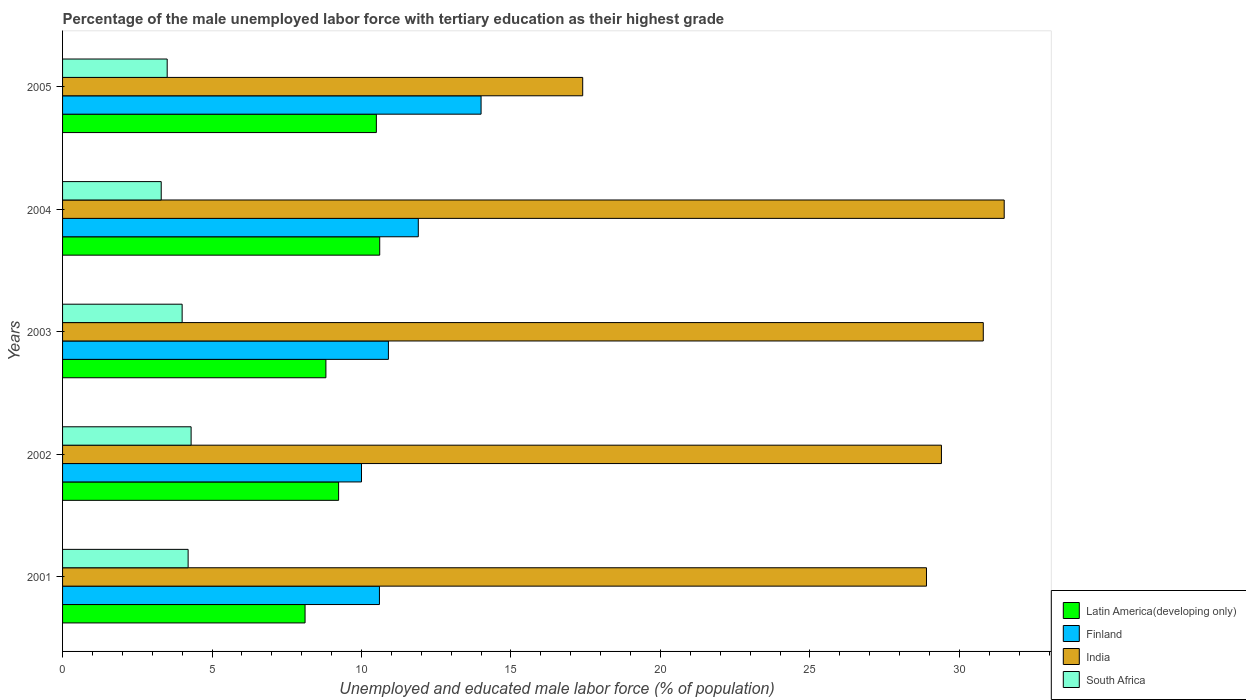How many groups of bars are there?
Keep it short and to the point. 5. Are the number of bars per tick equal to the number of legend labels?
Offer a terse response. Yes. How many bars are there on the 1st tick from the top?
Ensure brevity in your answer.  4. What is the label of the 1st group of bars from the top?
Ensure brevity in your answer.  2005. What is the percentage of the unemployed male labor force with tertiary education in India in 2002?
Offer a terse response. 29.4. Across all years, what is the maximum percentage of the unemployed male labor force with tertiary education in South Africa?
Keep it short and to the point. 4.3. Across all years, what is the minimum percentage of the unemployed male labor force with tertiary education in Latin America(developing only)?
Your response must be concise. 8.11. In which year was the percentage of the unemployed male labor force with tertiary education in South Africa minimum?
Provide a succinct answer. 2004. What is the total percentage of the unemployed male labor force with tertiary education in India in the graph?
Provide a succinct answer. 138. What is the difference between the percentage of the unemployed male labor force with tertiary education in India in 2003 and that in 2004?
Your response must be concise. -0.7. What is the average percentage of the unemployed male labor force with tertiary education in Finland per year?
Provide a succinct answer. 11.48. In the year 2002, what is the difference between the percentage of the unemployed male labor force with tertiary education in India and percentage of the unemployed male labor force with tertiary education in Latin America(developing only)?
Offer a very short reply. 20.17. What is the ratio of the percentage of the unemployed male labor force with tertiary education in Latin America(developing only) in 2003 to that in 2004?
Give a very brief answer. 0.83. Is the percentage of the unemployed male labor force with tertiary education in Latin America(developing only) in 2002 less than that in 2004?
Give a very brief answer. Yes. Is the difference between the percentage of the unemployed male labor force with tertiary education in India in 2003 and 2004 greater than the difference between the percentage of the unemployed male labor force with tertiary education in Latin America(developing only) in 2003 and 2004?
Make the answer very short. Yes. What is the difference between the highest and the second highest percentage of the unemployed male labor force with tertiary education in India?
Provide a short and direct response. 0.7. In how many years, is the percentage of the unemployed male labor force with tertiary education in South Africa greater than the average percentage of the unemployed male labor force with tertiary education in South Africa taken over all years?
Provide a short and direct response. 3. Is the sum of the percentage of the unemployed male labor force with tertiary education in Finland in 2002 and 2003 greater than the maximum percentage of the unemployed male labor force with tertiary education in Latin America(developing only) across all years?
Make the answer very short. Yes. What does the 2nd bar from the bottom in 2003 represents?
Ensure brevity in your answer.  Finland. Is it the case that in every year, the sum of the percentage of the unemployed male labor force with tertiary education in South Africa and percentage of the unemployed male labor force with tertiary education in Finland is greater than the percentage of the unemployed male labor force with tertiary education in Latin America(developing only)?
Provide a succinct answer. Yes. How many years are there in the graph?
Your answer should be compact. 5. Are the values on the major ticks of X-axis written in scientific E-notation?
Your answer should be very brief. No. Does the graph contain any zero values?
Offer a terse response. No. Does the graph contain grids?
Offer a very short reply. No. How many legend labels are there?
Ensure brevity in your answer.  4. How are the legend labels stacked?
Give a very brief answer. Vertical. What is the title of the graph?
Provide a succinct answer. Percentage of the male unemployed labor force with tertiary education as their highest grade. Does "Middle East & North Africa (all income levels)" appear as one of the legend labels in the graph?
Give a very brief answer. No. What is the label or title of the X-axis?
Offer a very short reply. Unemployed and educated male labor force (% of population). What is the label or title of the Y-axis?
Your answer should be very brief. Years. What is the Unemployed and educated male labor force (% of population) of Latin America(developing only) in 2001?
Your answer should be compact. 8.11. What is the Unemployed and educated male labor force (% of population) in Finland in 2001?
Keep it short and to the point. 10.6. What is the Unemployed and educated male labor force (% of population) of India in 2001?
Provide a short and direct response. 28.9. What is the Unemployed and educated male labor force (% of population) of South Africa in 2001?
Provide a short and direct response. 4.2. What is the Unemployed and educated male labor force (% of population) in Latin America(developing only) in 2002?
Keep it short and to the point. 9.23. What is the Unemployed and educated male labor force (% of population) of India in 2002?
Give a very brief answer. 29.4. What is the Unemployed and educated male labor force (% of population) in South Africa in 2002?
Offer a very short reply. 4.3. What is the Unemployed and educated male labor force (% of population) of Latin America(developing only) in 2003?
Your answer should be very brief. 8.81. What is the Unemployed and educated male labor force (% of population) of Finland in 2003?
Offer a terse response. 10.9. What is the Unemployed and educated male labor force (% of population) of India in 2003?
Offer a very short reply. 30.8. What is the Unemployed and educated male labor force (% of population) in Latin America(developing only) in 2004?
Your answer should be compact. 10.61. What is the Unemployed and educated male labor force (% of population) of Finland in 2004?
Keep it short and to the point. 11.9. What is the Unemployed and educated male labor force (% of population) in India in 2004?
Your response must be concise. 31.5. What is the Unemployed and educated male labor force (% of population) of South Africa in 2004?
Make the answer very short. 3.3. What is the Unemployed and educated male labor force (% of population) of Latin America(developing only) in 2005?
Your answer should be compact. 10.5. What is the Unemployed and educated male labor force (% of population) in Finland in 2005?
Give a very brief answer. 14. What is the Unemployed and educated male labor force (% of population) of India in 2005?
Ensure brevity in your answer.  17.4. What is the Unemployed and educated male labor force (% of population) in South Africa in 2005?
Your answer should be compact. 3.5. Across all years, what is the maximum Unemployed and educated male labor force (% of population) of Latin America(developing only)?
Your response must be concise. 10.61. Across all years, what is the maximum Unemployed and educated male labor force (% of population) in Finland?
Make the answer very short. 14. Across all years, what is the maximum Unemployed and educated male labor force (% of population) of India?
Your answer should be very brief. 31.5. Across all years, what is the maximum Unemployed and educated male labor force (% of population) of South Africa?
Make the answer very short. 4.3. Across all years, what is the minimum Unemployed and educated male labor force (% of population) in Latin America(developing only)?
Your answer should be very brief. 8.11. Across all years, what is the minimum Unemployed and educated male labor force (% of population) in India?
Make the answer very short. 17.4. Across all years, what is the minimum Unemployed and educated male labor force (% of population) in South Africa?
Ensure brevity in your answer.  3.3. What is the total Unemployed and educated male labor force (% of population) in Latin America(developing only) in the graph?
Keep it short and to the point. 47.26. What is the total Unemployed and educated male labor force (% of population) in Finland in the graph?
Your answer should be very brief. 57.4. What is the total Unemployed and educated male labor force (% of population) of India in the graph?
Keep it short and to the point. 138. What is the total Unemployed and educated male labor force (% of population) in South Africa in the graph?
Provide a succinct answer. 19.3. What is the difference between the Unemployed and educated male labor force (% of population) in Latin America(developing only) in 2001 and that in 2002?
Provide a short and direct response. -1.12. What is the difference between the Unemployed and educated male labor force (% of population) in Finland in 2001 and that in 2002?
Offer a very short reply. 0.6. What is the difference between the Unemployed and educated male labor force (% of population) in Latin America(developing only) in 2001 and that in 2003?
Offer a very short reply. -0.7. What is the difference between the Unemployed and educated male labor force (% of population) of Finland in 2001 and that in 2003?
Provide a succinct answer. -0.3. What is the difference between the Unemployed and educated male labor force (% of population) in India in 2001 and that in 2003?
Your response must be concise. -1.9. What is the difference between the Unemployed and educated male labor force (% of population) in Latin America(developing only) in 2001 and that in 2004?
Your response must be concise. -2.5. What is the difference between the Unemployed and educated male labor force (% of population) in Finland in 2001 and that in 2004?
Your response must be concise. -1.3. What is the difference between the Unemployed and educated male labor force (% of population) of India in 2001 and that in 2004?
Your answer should be very brief. -2.6. What is the difference between the Unemployed and educated male labor force (% of population) in Latin America(developing only) in 2001 and that in 2005?
Your response must be concise. -2.38. What is the difference between the Unemployed and educated male labor force (% of population) in Finland in 2001 and that in 2005?
Offer a terse response. -3.4. What is the difference between the Unemployed and educated male labor force (% of population) in India in 2001 and that in 2005?
Provide a short and direct response. 11.5. What is the difference between the Unemployed and educated male labor force (% of population) in South Africa in 2001 and that in 2005?
Keep it short and to the point. 0.7. What is the difference between the Unemployed and educated male labor force (% of population) of Latin America(developing only) in 2002 and that in 2003?
Give a very brief answer. 0.43. What is the difference between the Unemployed and educated male labor force (% of population) of Finland in 2002 and that in 2003?
Offer a terse response. -0.9. What is the difference between the Unemployed and educated male labor force (% of population) of India in 2002 and that in 2003?
Your answer should be very brief. -1.4. What is the difference between the Unemployed and educated male labor force (% of population) of South Africa in 2002 and that in 2003?
Give a very brief answer. 0.3. What is the difference between the Unemployed and educated male labor force (% of population) in Latin America(developing only) in 2002 and that in 2004?
Ensure brevity in your answer.  -1.37. What is the difference between the Unemployed and educated male labor force (% of population) of India in 2002 and that in 2004?
Ensure brevity in your answer.  -2.1. What is the difference between the Unemployed and educated male labor force (% of population) in South Africa in 2002 and that in 2004?
Offer a terse response. 1. What is the difference between the Unemployed and educated male labor force (% of population) in Latin America(developing only) in 2002 and that in 2005?
Provide a short and direct response. -1.26. What is the difference between the Unemployed and educated male labor force (% of population) in Finland in 2002 and that in 2005?
Provide a succinct answer. -4. What is the difference between the Unemployed and educated male labor force (% of population) of South Africa in 2002 and that in 2005?
Make the answer very short. 0.8. What is the difference between the Unemployed and educated male labor force (% of population) of Latin America(developing only) in 2003 and that in 2004?
Offer a terse response. -1.8. What is the difference between the Unemployed and educated male labor force (% of population) of Finland in 2003 and that in 2004?
Make the answer very short. -1. What is the difference between the Unemployed and educated male labor force (% of population) in Latin America(developing only) in 2003 and that in 2005?
Provide a succinct answer. -1.69. What is the difference between the Unemployed and educated male labor force (% of population) in Finland in 2003 and that in 2005?
Ensure brevity in your answer.  -3.1. What is the difference between the Unemployed and educated male labor force (% of population) of South Africa in 2003 and that in 2005?
Your answer should be compact. 0.5. What is the difference between the Unemployed and educated male labor force (% of population) in Latin America(developing only) in 2004 and that in 2005?
Ensure brevity in your answer.  0.11. What is the difference between the Unemployed and educated male labor force (% of population) in India in 2004 and that in 2005?
Provide a short and direct response. 14.1. What is the difference between the Unemployed and educated male labor force (% of population) of South Africa in 2004 and that in 2005?
Ensure brevity in your answer.  -0.2. What is the difference between the Unemployed and educated male labor force (% of population) in Latin America(developing only) in 2001 and the Unemployed and educated male labor force (% of population) in Finland in 2002?
Give a very brief answer. -1.89. What is the difference between the Unemployed and educated male labor force (% of population) in Latin America(developing only) in 2001 and the Unemployed and educated male labor force (% of population) in India in 2002?
Offer a very short reply. -21.29. What is the difference between the Unemployed and educated male labor force (% of population) of Latin America(developing only) in 2001 and the Unemployed and educated male labor force (% of population) of South Africa in 2002?
Offer a terse response. 3.81. What is the difference between the Unemployed and educated male labor force (% of population) in Finland in 2001 and the Unemployed and educated male labor force (% of population) in India in 2002?
Offer a very short reply. -18.8. What is the difference between the Unemployed and educated male labor force (% of population) in India in 2001 and the Unemployed and educated male labor force (% of population) in South Africa in 2002?
Offer a terse response. 24.6. What is the difference between the Unemployed and educated male labor force (% of population) of Latin America(developing only) in 2001 and the Unemployed and educated male labor force (% of population) of Finland in 2003?
Give a very brief answer. -2.79. What is the difference between the Unemployed and educated male labor force (% of population) in Latin America(developing only) in 2001 and the Unemployed and educated male labor force (% of population) in India in 2003?
Offer a very short reply. -22.69. What is the difference between the Unemployed and educated male labor force (% of population) in Latin America(developing only) in 2001 and the Unemployed and educated male labor force (% of population) in South Africa in 2003?
Your response must be concise. 4.11. What is the difference between the Unemployed and educated male labor force (% of population) of Finland in 2001 and the Unemployed and educated male labor force (% of population) of India in 2003?
Provide a short and direct response. -20.2. What is the difference between the Unemployed and educated male labor force (% of population) in Finland in 2001 and the Unemployed and educated male labor force (% of population) in South Africa in 2003?
Offer a terse response. 6.6. What is the difference between the Unemployed and educated male labor force (% of population) in India in 2001 and the Unemployed and educated male labor force (% of population) in South Africa in 2003?
Give a very brief answer. 24.9. What is the difference between the Unemployed and educated male labor force (% of population) of Latin America(developing only) in 2001 and the Unemployed and educated male labor force (% of population) of Finland in 2004?
Offer a terse response. -3.79. What is the difference between the Unemployed and educated male labor force (% of population) in Latin America(developing only) in 2001 and the Unemployed and educated male labor force (% of population) in India in 2004?
Make the answer very short. -23.39. What is the difference between the Unemployed and educated male labor force (% of population) in Latin America(developing only) in 2001 and the Unemployed and educated male labor force (% of population) in South Africa in 2004?
Give a very brief answer. 4.81. What is the difference between the Unemployed and educated male labor force (% of population) in Finland in 2001 and the Unemployed and educated male labor force (% of population) in India in 2004?
Provide a short and direct response. -20.9. What is the difference between the Unemployed and educated male labor force (% of population) of Finland in 2001 and the Unemployed and educated male labor force (% of population) of South Africa in 2004?
Provide a succinct answer. 7.3. What is the difference between the Unemployed and educated male labor force (% of population) in India in 2001 and the Unemployed and educated male labor force (% of population) in South Africa in 2004?
Your answer should be compact. 25.6. What is the difference between the Unemployed and educated male labor force (% of population) in Latin America(developing only) in 2001 and the Unemployed and educated male labor force (% of population) in Finland in 2005?
Your response must be concise. -5.89. What is the difference between the Unemployed and educated male labor force (% of population) in Latin America(developing only) in 2001 and the Unemployed and educated male labor force (% of population) in India in 2005?
Provide a succinct answer. -9.29. What is the difference between the Unemployed and educated male labor force (% of population) of Latin America(developing only) in 2001 and the Unemployed and educated male labor force (% of population) of South Africa in 2005?
Provide a short and direct response. 4.61. What is the difference between the Unemployed and educated male labor force (% of population) in Finland in 2001 and the Unemployed and educated male labor force (% of population) in India in 2005?
Offer a very short reply. -6.8. What is the difference between the Unemployed and educated male labor force (% of population) of India in 2001 and the Unemployed and educated male labor force (% of population) of South Africa in 2005?
Ensure brevity in your answer.  25.4. What is the difference between the Unemployed and educated male labor force (% of population) of Latin America(developing only) in 2002 and the Unemployed and educated male labor force (% of population) of Finland in 2003?
Keep it short and to the point. -1.67. What is the difference between the Unemployed and educated male labor force (% of population) of Latin America(developing only) in 2002 and the Unemployed and educated male labor force (% of population) of India in 2003?
Your response must be concise. -21.57. What is the difference between the Unemployed and educated male labor force (% of population) in Latin America(developing only) in 2002 and the Unemployed and educated male labor force (% of population) in South Africa in 2003?
Give a very brief answer. 5.23. What is the difference between the Unemployed and educated male labor force (% of population) of Finland in 2002 and the Unemployed and educated male labor force (% of population) of India in 2003?
Ensure brevity in your answer.  -20.8. What is the difference between the Unemployed and educated male labor force (% of population) of India in 2002 and the Unemployed and educated male labor force (% of population) of South Africa in 2003?
Provide a short and direct response. 25.4. What is the difference between the Unemployed and educated male labor force (% of population) of Latin America(developing only) in 2002 and the Unemployed and educated male labor force (% of population) of Finland in 2004?
Offer a terse response. -2.67. What is the difference between the Unemployed and educated male labor force (% of population) in Latin America(developing only) in 2002 and the Unemployed and educated male labor force (% of population) in India in 2004?
Ensure brevity in your answer.  -22.27. What is the difference between the Unemployed and educated male labor force (% of population) in Latin America(developing only) in 2002 and the Unemployed and educated male labor force (% of population) in South Africa in 2004?
Offer a terse response. 5.93. What is the difference between the Unemployed and educated male labor force (% of population) of Finland in 2002 and the Unemployed and educated male labor force (% of population) of India in 2004?
Provide a short and direct response. -21.5. What is the difference between the Unemployed and educated male labor force (% of population) of India in 2002 and the Unemployed and educated male labor force (% of population) of South Africa in 2004?
Make the answer very short. 26.1. What is the difference between the Unemployed and educated male labor force (% of population) of Latin America(developing only) in 2002 and the Unemployed and educated male labor force (% of population) of Finland in 2005?
Your response must be concise. -4.77. What is the difference between the Unemployed and educated male labor force (% of population) of Latin America(developing only) in 2002 and the Unemployed and educated male labor force (% of population) of India in 2005?
Your response must be concise. -8.17. What is the difference between the Unemployed and educated male labor force (% of population) of Latin America(developing only) in 2002 and the Unemployed and educated male labor force (% of population) of South Africa in 2005?
Your answer should be very brief. 5.73. What is the difference between the Unemployed and educated male labor force (% of population) in Finland in 2002 and the Unemployed and educated male labor force (% of population) in India in 2005?
Offer a very short reply. -7.4. What is the difference between the Unemployed and educated male labor force (% of population) of Finland in 2002 and the Unemployed and educated male labor force (% of population) of South Africa in 2005?
Your response must be concise. 6.5. What is the difference between the Unemployed and educated male labor force (% of population) in India in 2002 and the Unemployed and educated male labor force (% of population) in South Africa in 2005?
Make the answer very short. 25.9. What is the difference between the Unemployed and educated male labor force (% of population) of Latin America(developing only) in 2003 and the Unemployed and educated male labor force (% of population) of Finland in 2004?
Keep it short and to the point. -3.09. What is the difference between the Unemployed and educated male labor force (% of population) of Latin America(developing only) in 2003 and the Unemployed and educated male labor force (% of population) of India in 2004?
Give a very brief answer. -22.69. What is the difference between the Unemployed and educated male labor force (% of population) of Latin America(developing only) in 2003 and the Unemployed and educated male labor force (% of population) of South Africa in 2004?
Offer a very short reply. 5.51. What is the difference between the Unemployed and educated male labor force (% of population) of Finland in 2003 and the Unemployed and educated male labor force (% of population) of India in 2004?
Ensure brevity in your answer.  -20.6. What is the difference between the Unemployed and educated male labor force (% of population) in Finland in 2003 and the Unemployed and educated male labor force (% of population) in South Africa in 2004?
Make the answer very short. 7.6. What is the difference between the Unemployed and educated male labor force (% of population) of Latin America(developing only) in 2003 and the Unemployed and educated male labor force (% of population) of Finland in 2005?
Your answer should be very brief. -5.19. What is the difference between the Unemployed and educated male labor force (% of population) of Latin America(developing only) in 2003 and the Unemployed and educated male labor force (% of population) of India in 2005?
Provide a succinct answer. -8.59. What is the difference between the Unemployed and educated male labor force (% of population) in Latin America(developing only) in 2003 and the Unemployed and educated male labor force (% of population) in South Africa in 2005?
Keep it short and to the point. 5.31. What is the difference between the Unemployed and educated male labor force (% of population) in India in 2003 and the Unemployed and educated male labor force (% of population) in South Africa in 2005?
Your response must be concise. 27.3. What is the difference between the Unemployed and educated male labor force (% of population) of Latin America(developing only) in 2004 and the Unemployed and educated male labor force (% of population) of Finland in 2005?
Ensure brevity in your answer.  -3.39. What is the difference between the Unemployed and educated male labor force (% of population) in Latin America(developing only) in 2004 and the Unemployed and educated male labor force (% of population) in India in 2005?
Offer a terse response. -6.79. What is the difference between the Unemployed and educated male labor force (% of population) in Latin America(developing only) in 2004 and the Unemployed and educated male labor force (% of population) in South Africa in 2005?
Keep it short and to the point. 7.11. What is the average Unemployed and educated male labor force (% of population) in Latin America(developing only) per year?
Provide a short and direct response. 9.45. What is the average Unemployed and educated male labor force (% of population) in Finland per year?
Keep it short and to the point. 11.48. What is the average Unemployed and educated male labor force (% of population) of India per year?
Offer a terse response. 27.6. What is the average Unemployed and educated male labor force (% of population) of South Africa per year?
Give a very brief answer. 3.86. In the year 2001, what is the difference between the Unemployed and educated male labor force (% of population) of Latin America(developing only) and Unemployed and educated male labor force (% of population) of Finland?
Provide a succinct answer. -2.49. In the year 2001, what is the difference between the Unemployed and educated male labor force (% of population) in Latin America(developing only) and Unemployed and educated male labor force (% of population) in India?
Ensure brevity in your answer.  -20.79. In the year 2001, what is the difference between the Unemployed and educated male labor force (% of population) of Latin America(developing only) and Unemployed and educated male labor force (% of population) of South Africa?
Make the answer very short. 3.91. In the year 2001, what is the difference between the Unemployed and educated male labor force (% of population) in Finland and Unemployed and educated male labor force (% of population) in India?
Keep it short and to the point. -18.3. In the year 2001, what is the difference between the Unemployed and educated male labor force (% of population) of India and Unemployed and educated male labor force (% of population) of South Africa?
Your answer should be very brief. 24.7. In the year 2002, what is the difference between the Unemployed and educated male labor force (% of population) in Latin America(developing only) and Unemployed and educated male labor force (% of population) in Finland?
Offer a terse response. -0.77. In the year 2002, what is the difference between the Unemployed and educated male labor force (% of population) of Latin America(developing only) and Unemployed and educated male labor force (% of population) of India?
Your response must be concise. -20.17. In the year 2002, what is the difference between the Unemployed and educated male labor force (% of population) of Latin America(developing only) and Unemployed and educated male labor force (% of population) of South Africa?
Make the answer very short. 4.93. In the year 2002, what is the difference between the Unemployed and educated male labor force (% of population) in Finland and Unemployed and educated male labor force (% of population) in India?
Keep it short and to the point. -19.4. In the year 2002, what is the difference between the Unemployed and educated male labor force (% of population) of India and Unemployed and educated male labor force (% of population) of South Africa?
Keep it short and to the point. 25.1. In the year 2003, what is the difference between the Unemployed and educated male labor force (% of population) of Latin America(developing only) and Unemployed and educated male labor force (% of population) of Finland?
Keep it short and to the point. -2.09. In the year 2003, what is the difference between the Unemployed and educated male labor force (% of population) in Latin America(developing only) and Unemployed and educated male labor force (% of population) in India?
Give a very brief answer. -21.99. In the year 2003, what is the difference between the Unemployed and educated male labor force (% of population) in Latin America(developing only) and Unemployed and educated male labor force (% of population) in South Africa?
Provide a short and direct response. 4.81. In the year 2003, what is the difference between the Unemployed and educated male labor force (% of population) in Finland and Unemployed and educated male labor force (% of population) in India?
Your answer should be compact. -19.9. In the year 2003, what is the difference between the Unemployed and educated male labor force (% of population) in Finland and Unemployed and educated male labor force (% of population) in South Africa?
Keep it short and to the point. 6.9. In the year 2003, what is the difference between the Unemployed and educated male labor force (% of population) of India and Unemployed and educated male labor force (% of population) of South Africa?
Ensure brevity in your answer.  26.8. In the year 2004, what is the difference between the Unemployed and educated male labor force (% of population) in Latin America(developing only) and Unemployed and educated male labor force (% of population) in Finland?
Provide a succinct answer. -1.29. In the year 2004, what is the difference between the Unemployed and educated male labor force (% of population) of Latin America(developing only) and Unemployed and educated male labor force (% of population) of India?
Your answer should be very brief. -20.89. In the year 2004, what is the difference between the Unemployed and educated male labor force (% of population) of Latin America(developing only) and Unemployed and educated male labor force (% of population) of South Africa?
Your answer should be compact. 7.31. In the year 2004, what is the difference between the Unemployed and educated male labor force (% of population) of Finland and Unemployed and educated male labor force (% of population) of India?
Your answer should be compact. -19.6. In the year 2004, what is the difference between the Unemployed and educated male labor force (% of population) in India and Unemployed and educated male labor force (% of population) in South Africa?
Keep it short and to the point. 28.2. In the year 2005, what is the difference between the Unemployed and educated male labor force (% of population) in Latin America(developing only) and Unemployed and educated male labor force (% of population) in Finland?
Your response must be concise. -3.5. In the year 2005, what is the difference between the Unemployed and educated male labor force (% of population) in Latin America(developing only) and Unemployed and educated male labor force (% of population) in India?
Offer a terse response. -6.9. In the year 2005, what is the difference between the Unemployed and educated male labor force (% of population) of Latin America(developing only) and Unemployed and educated male labor force (% of population) of South Africa?
Ensure brevity in your answer.  7. In the year 2005, what is the difference between the Unemployed and educated male labor force (% of population) of Finland and Unemployed and educated male labor force (% of population) of India?
Offer a terse response. -3.4. In the year 2005, what is the difference between the Unemployed and educated male labor force (% of population) of Finland and Unemployed and educated male labor force (% of population) of South Africa?
Keep it short and to the point. 10.5. What is the ratio of the Unemployed and educated male labor force (% of population) of Latin America(developing only) in 2001 to that in 2002?
Make the answer very short. 0.88. What is the ratio of the Unemployed and educated male labor force (% of population) in Finland in 2001 to that in 2002?
Make the answer very short. 1.06. What is the ratio of the Unemployed and educated male labor force (% of population) in South Africa in 2001 to that in 2002?
Give a very brief answer. 0.98. What is the ratio of the Unemployed and educated male labor force (% of population) in Latin America(developing only) in 2001 to that in 2003?
Ensure brevity in your answer.  0.92. What is the ratio of the Unemployed and educated male labor force (% of population) of Finland in 2001 to that in 2003?
Your response must be concise. 0.97. What is the ratio of the Unemployed and educated male labor force (% of population) in India in 2001 to that in 2003?
Offer a very short reply. 0.94. What is the ratio of the Unemployed and educated male labor force (% of population) in South Africa in 2001 to that in 2003?
Make the answer very short. 1.05. What is the ratio of the Unemployed and educated male labor force (% of population) of Latin America(developing only) in 2001 to that in 2004?
Offer a terse response. 0.76. What is the ratio of the Unemployed and educated male labor force (% of population) in Finland in 2001 to that in 2004?
Provide a succinct answer. 0.89. What is the ratio of the Unemployed and educated male labor force (% of population) in India in 2001 to that in 2004?
Offer a very short reply. 0.92. What is the ratio of the Unemployed and educated male labor force (% of population) in South Africa in 2001 to that in 2004?
Provide a short and direct response. 1.27. What is the ratio of the Unemployed and educated male labor force (% of population) of Latin America(developing only) in 2001 to that in 2005?
Your answer should be compact. 0.77. What is the ratio of the Unemployed and educated male labor force (% of population) in Finland in 2001 to that in 2005?
Offer a terse response. 0.76. What is the ratio of the Unemployed and educated male labor force (% of population) of India in 2001 to that in 2005?
Your answer should be compact. 1.66. What is the ratio of the Unemployed and educated male labor force (% of population) of South Africa in 2001 to that in 2005?
Ensure brevity in your answer.  1.2. What is the ratio of the Unemployed and educated male labor force (% of population) in Latin America(developing only) in 2002 to that in 2003?
Offer a very short reply. 1.05. What is the ratio of the Unemployed and educated male labor force (% of population) in Finland in 2002 to that in 2003?
Your response must be concise. 0.92. What is the ratio of the Unemployed and educated male labor force (% of population) of India in 2002 to that in 2003?
Your answer should be very brief. 0.95. What is the ratio of the Unemployed and educated male labor force (% of population) of South Africa in 2002 to that in 2003?
Provide a succinct answer. 1.07. What is the ratio of the Unemployed and educated male labor force (% of population) of Latin America(developing only) in 2002 to that in 2004?
Ensure brevity in your answer.  0.87. What is the ratio of the Unemployed and educated male labor force (% of population) of Finland in 2002 to that in 2004?
Ensure brevity in your answer.  0.84. What is the ratio of the Unemployed and educated male labor force (% of population) in India in 2002 to that in 2004?
Your response must be concise. 0.93. What is the ratio of the Unemployed and educated male labor force (% of population) in South Africa in 2002 to that in 2004?
Make the answer very short. 1.3. What is the ratio of the Unemployed and educated male labor force (% of population) in Latin America(developing only) in 2002 to that in 2005?
Your response must be concise. 0.88. What is the ratio of the Unemployed and educated male labor force (% of population) of India in 2002 to that in 2005?
Your response must be concise. 1.69. What is the ratio of the Unemployed and educated male labor force (% of population) in South Africa in 2002 to that in 2005?
Give a very brief answer. 1.23. What is the ratio of the Unemployed and educated male labor force (% of population) of Latin America(developing only) in 2003 to that in 2004?
Make the answer very short. 0.83. What is the ratio of the Unemployed and educated male labor force (% of population) of Finland in 2003 to that in 2004?
Make the answer very short. 0.92. What is the ratio of the Unemployed and educated male labor force (% of population) in India in 2003 to that in 2004?
Provide a short and direct response. 0.98. What is the ratio of the Unemployed and educated male labor force (% of population) of South Africa in 2003 to that in 2004?
Give a very brief answer. 1.21. What is the ratio of the Unemployed and educated male labor force (% of population) of Latin America(developing only) in 2003 to that in 2005?
Provide a short and direct response. 0.84. What is the ratio of the Unemployed and educated male labor force (% of population) of Finland in 2003 to that in 2005?
Ensure brevity in your answer.  0.78. What is the ratio of the Unemployed and educated male labor force (% of population) in India in 2003 to that in 2005?
Your answer should be compact. 1.77. What is the ratio of the Unemployed and educated male labor force (% of population) in South Africa in 2003 to that in 2005?
Offer a terse response. 1.14. What is the ratio of the Unemployed and educated male labor force (% of population) of Latin America(developing only) in 2004 to that in 2005?
Make the answer very short. 1.01. What is the ratio of the Unemployed and educated male labor force (% of population) in Finland in 2004 to that in 2005?
Provide a succinct answer. 0.85. What is the ratio of the Unemployed and educated male labor force (% of population) in India in 2004 to that in 2005?
Ensure brevity in your answer.  1.81. What is the ratio of the Unemployed and educated male labor force (% of population) in South Africa in 2004 to that in 2005?
Make the answer very short. 0.94. What is the difference between the highest and the second highest Unemployed and educated male labor force (% of population) in Latin America(developing only)?
Keep it short and to the point. 0.11. What is the difference between the highest and the second highest Unemployed and educated male labor force (% of population) in Finland?
Offer a very short reply. 2.1. What is the difference between the highest and the second highest Unemployed and educated male labor force (% of population) in India?
Provide a succinct answer. 0.7. What is the difference between the highest and the second highest Unemployed and educated male labor force (% of population) of South Africa?
Offer a very short reply. 0.1. What is the difference between the highest and the lowest Unemployed and educated male labor force (% of population) of Latin America(developing only)?
Keep it short and to the point. 2.5. What is the difference between the highest and the lowest Unemployed and educated male labor force (% of population) in India?
Ensure brevity in your answer.  14.1. 